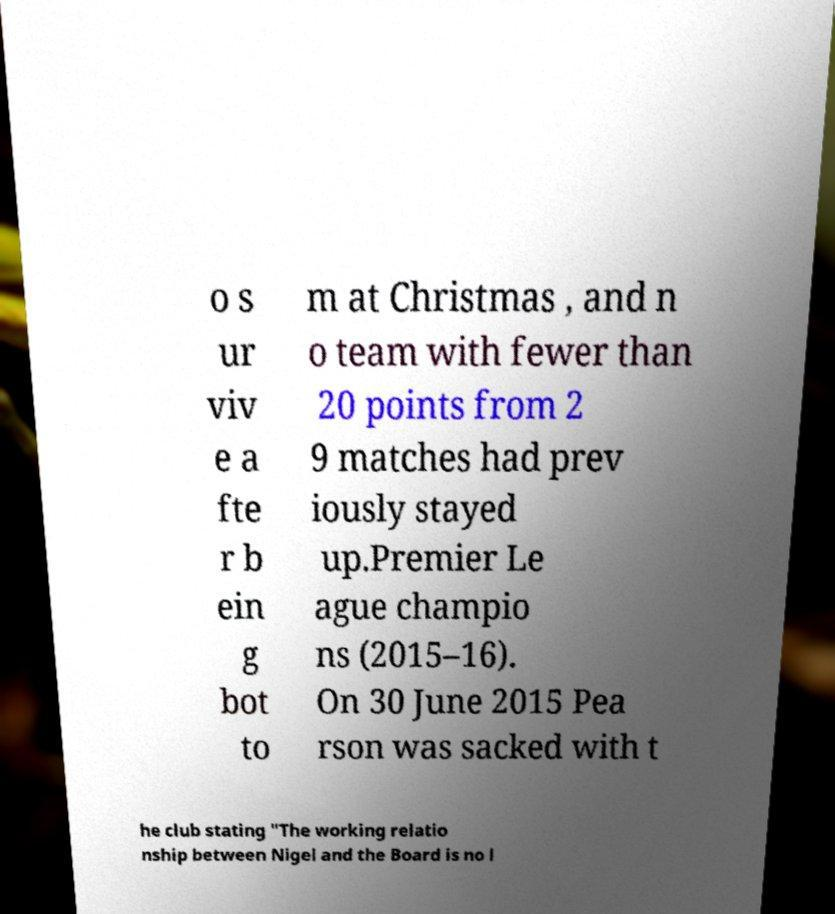I need the written content from this picture converted into text. Can you do that? o s ur viv e a fte r b ein g bot to m at Christmas , and n o team with fewer than 20 points from 2 9 matches had prev iously stayed up.Premier Le ague champio ns (2015–16). On 30 June 2015 Pea rson was sacked with t he club stating "The working relatio nship between Nigel and the Board is no l 